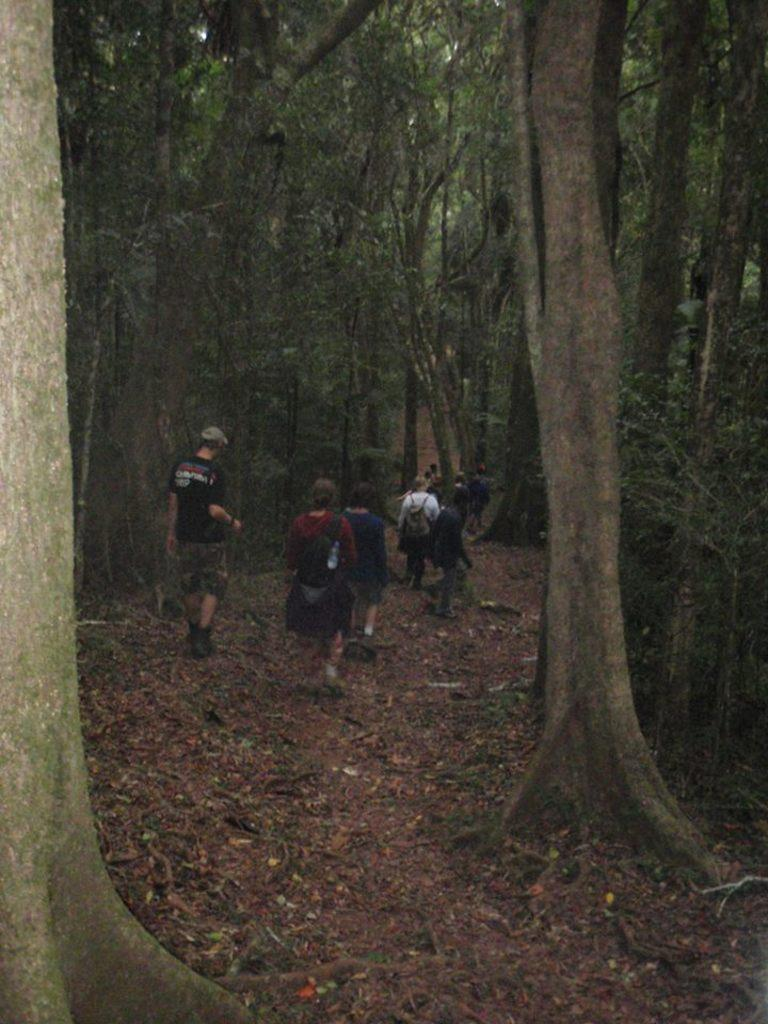What are the people in the image doing? The people in the image are walking. On what surface are the people walking? The people are walking on the ground. Where is the ground located? The ground is in a forest. What can be seen around the area where the people are walking? There are trees surrounding the area. What is present on the ground in the forest? Dry leaves and sand are visible on the ground. Who is the owner of the heart-shaped chain in the image? There is no heart-shaped chain present in the image. 